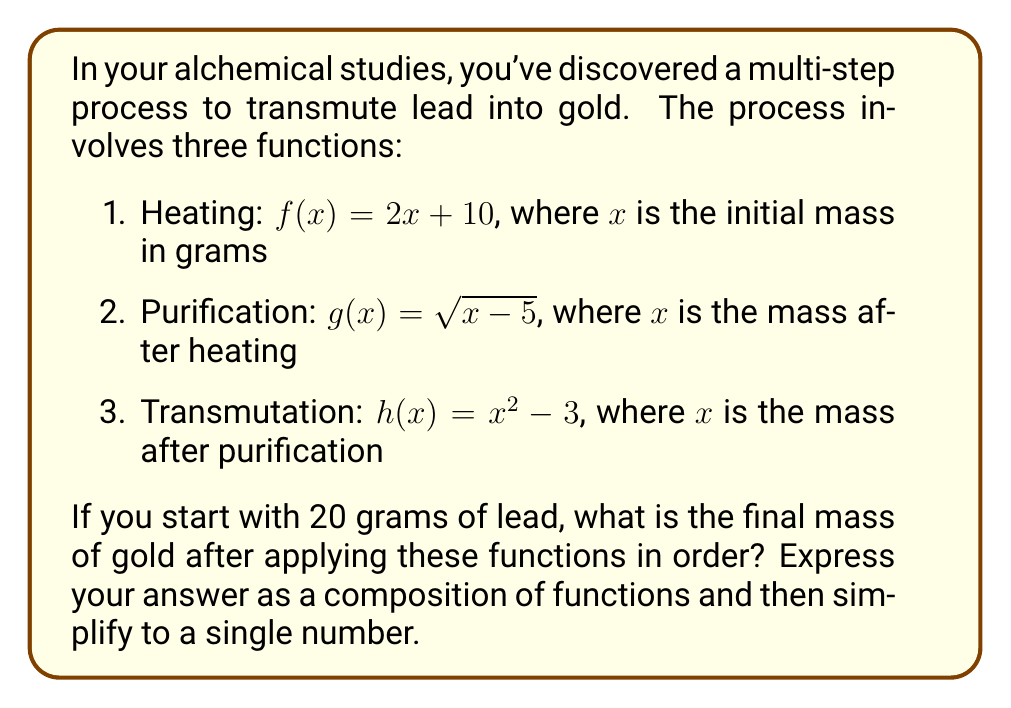Show me your answer to this math problem. Let's approach this step-by-step:

1) First, we need to compose the functions in the correct order. The composition will be $h(g(f(x)))$, where $x = 20$ (our initial mass of lead).

2) Let's start from the innermost function and work our way out:

   $f(20) = 2(20) + 10 = 50$

3) Now we apply $g$ to this result:

   $g(50) = \sqrt{50 - 5} = \sqrt{45} = 3\sqrt{5}$

4) Finally, we apply $h$ to this result:

   $h(3\sqrt{5}) = (3\sqrt{5})^2 - 3 = 45 - 3 = 42$

5) Therefore, the composition of functions can be written as:

   $h(g(f(20))) = 42$

6) To express this as a general composition for any initial mass $x$:

   $h(g(f(x))) = (\sqrt{(2x + 10) - 5})^2 - 3$
                $= (\sqrt{2x + 5})^2 - 3$
                $= 2x + 5 - 3$
                $= 2x + 2$

7) Substituting $x = 20$ into this general form:

   $h(g(f(20))) = 2(20) + 2 = 42$

This confirms our step-by-step calculation.
Answer: $h(g(f(20))) = 42$ grams 